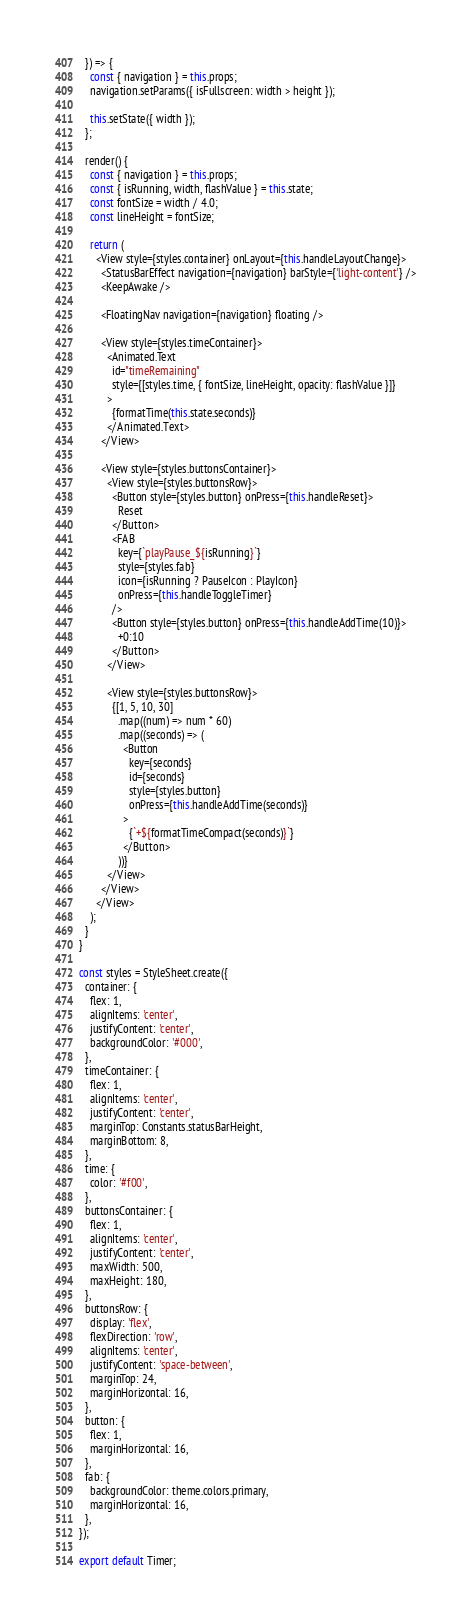<code> <loc_0><loc_0><loc_500><loc_500><_JavaScript_>  }) => {
    const { navigation } = this.props;
    navigation.setParams({ isFullscreen: width > height });

    this.setState({ width });
  };

  render() {
    const { navigation } = this.props;
    const { isRunning, width, flashValue } = this.state;
    const fontSize = width / 4.0;
    const lineHeight = fontSize;

    return (
      <View style={styles.container} onLayout={this.handleLayoutChange}>
        <StatusBarEffect navigation={navigation} barStyle={'light-content'} />
        <KeepAwake />

        <FloatingNav navigation={navigation} floating />

        <View style={styles.timeContainer}>
          <Animated.Text
            id="timeRemaining"
            style={[styles.time, { fontSize, lineHeight, opacity: flashValue }]}
          >
            {formatTime(this.state.seconds)}
          </Animated.Text>
        </View>

        <View style={styles.buttonsContainer}>
          <View style={styles.buttonsRow}>
            <Button style={styles.button} onPress={this.handleReset}>
              Reset
            </Button>
            <FAB
              key={`playPause_${isRunning}`}
              style={styles.fab}
              icon={isRunning ? PauseIcon : PlayIcon}
              onPress={this.handleToggleTimer}
            />
            <Button style={styles.button} onPress={this.handleAddTime(10)}>
              +0:10
            </Button>
          </View>

          <View style={styles.buttonsRow}>
            {[1, 5, 10, 30]
              .map((num) => num * 60)
              .map((seconds) => (
                <Button
                  key={seconds}
                  id={seconds}
                  style={styles.button}
                  onPress={this.handleAddTime(seconds)}
                >
                  {`+${formatTimeCompact(seconds)}`}
                </Button>
              ))}
          </View>
        </View>
      </View>
    );
  }
}

const styles = StyleSheet.create({
  container: {
    flex: 1,
    alignItems: 'center',
    justifyContent: 'center',
    backgroundColor: '#000',
  },
  timeContainer: {
    flex: 1,
    alignItems: 'center',
    justifyContent: 'center',
    marginTop: Constants.statusBarHeight,
    marginBottom: 8,
  },
  time: {
    color: '#f00',
  },
  buttonsContainer: {
    flex: 1,
    alignItems: 'center',
    justifyContent: 'center',
    maxWidth: 500,
    maxHeight: 180,
  },
  buttonsRow: {
    display: 'flex',
    flexDirection: 'row',
    alignItems: 'center',
    justifyContent: 'space-between',
    marginTop: 24,
    marginHorizontal: 16,
  },
  button: {
    flex: 1,
    marginHorizontal: 16,
  },
  fab: {
    backgroundColor: theme.colors.primary,
    marginHorizontal: 16,
  },
});

export default Timer;
</code> 